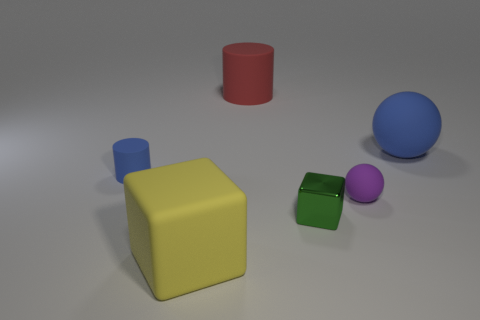What is the material of the yellow thing that is the same shape as the small green thing?
Offer a very short reply. Rubber. Do the purple matte thing and the large red thing have the same shape?
Offer a very short reply. No. There is a small rubber object that is on the left side of the tiny metallic object; what number of balls are behind it?
Ensure brevity in your answer.  1. What is the shape of the yellow object that is made of the same material as the small purple sphere?
Keep it short and to the point. Cube. How many purple things are either large rubber spheres or matte cylinders?
Keep it short and to the point. 0. Are there any rubber cylinders on the left side of the blue matte object that is left of the blue thing that is to the right of the yellow rubber block?
Offer a very short reply. No. Is the number of small metallic things less than the number of gray blocks?
Your answer should be compact. No. Is the shape of the small matte object that is to the right of the big red rubber object the same as  the small green shiny thing?
Offer a terse response. No. Are there any big cyan metallic cubes?
Your response must be concise. No. What is the color of the cylinder that is left of the big thing in front of the rubber sphere that is behind the blue cylinder?
Your response must be concise. Blue. 